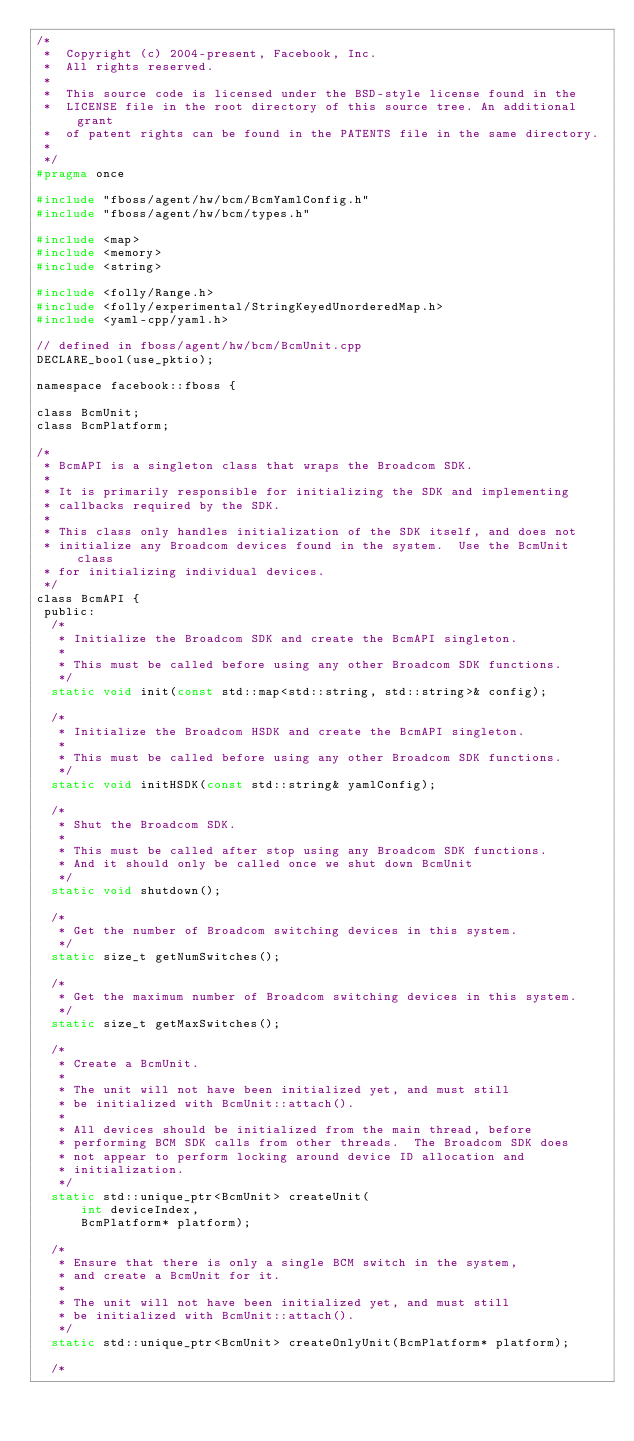Convert code to text. <code><loc_0><loc_0><loc_500><loc_500><_C_>/*
 *  Copyright (c) 2004-present, Facebook, Inc.
 *  All rights reserved.
 *
 *  This source code is licensed under the BSD-style license found in the
 *  LICENSE file in the root directory of this source tree. An additional grant
 *  of patent rights can be found in the PATENTS file in the same directory.
 *
 */
#pragma once

#include "fboss/agent/hw/bcm/BcmYamlConfig.h"
#include "fboss/agent/hw/bcm/types.h"

#include <map>
#include <memory>
#include <string>

#include <folly/Range.h>
#include <folly/experimental/StringKeyedUnorderedMap.h>
#include <yaml-cpp/yaml.h>

// defined in fboss/agent/hw/bcm/BcmUnit.cpp
DECLARE_bool(use_pktio);

namespace facebook::fboss {

class BcmUnit;
class BcmPlatform;

/*
 * BcmAPI is a singleton class that wraps the Broadcom SDK.
 *
 * It is primarily responsible for initializing the SDK and implementing
 * callbacks required by the SDK.
 *
 * This class only handles initialization of the SDK itself, and does not
 * initialize any Broadcom devices found in the system.  Use the BcmUnit class
 * for initializing individual devices.
 */
class BcmAPI {
 public:
  /*
   * Initialize the Broadcom SDK and create the BcmAPI singleton.
   *
   * This must be called before using any other Broadcom SDK functions.
   */
  static void init(const std::map<std::string, std::string>& config);

  /*
   * Initialize the Broadcom HSDK and create the BcmAPI singleton.
   *
   * This must be called before using any other Broadcom SDK functions.
   */
  static void initHSDK(const std::string& yamlConfig);

  /*
   * Shut the Broadcom SDK.
   *
   * This must be called after stop using any Broadcom SDK functions.
   * And it should only be called once we shut down BcmUnit
   */
  static void shutdown();

  /*
   * Get the number of Broadcom switching devices in this system.
   */
  static size_t getNumSwitches();

  /*
   * Get the maximum number of Broadcom switching devices in this system.
   */
  static size_t getMaxSwitches();

  /*
   * Create a BcmUnit.
   *
   * The unit will not have been initialized yet, and must still
   * be initialized with BcmUnit::attach().
   *
   * All devices should be initialized from the main thread, before
   * performing BCM SDK calls from other threads.  The Broadcom SDK does
   * not appear to perform locking around device ID allocation and
   * initialization.
   */
  static std::unique_ptr<BcmUnit> createUnit(
      int deviceIndex,
      BcmPlatform* platform);

  /*
   * Ensure that there is only a single BCM switch in the system,
   * and create a BcmUnit for it.
   *
   * The unit will not have been initialized yet, and must still
   * be initialized with BcmUnit::attach().
   */
  static std::unique_ptr<BcmUnit> createOnlyUnit(BcmPlatform* platform);

  /*</code> 